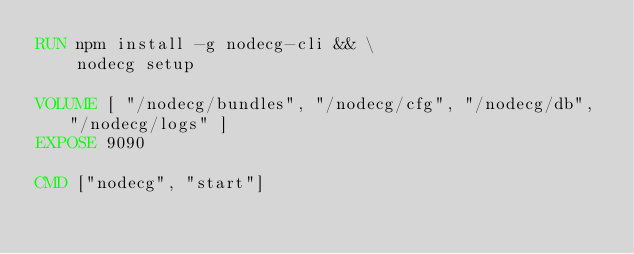<code> <loc_0><loc_0><loc_500><loc_500><_Dockerfile_>RUN npm install -g nodecg-cli && \
    nodecg setup

VOLUME [ "/nodecg/bundles", "/nodecg/cfg", "/nodecg/db", "/nodecg/logs" ]
EXPOSE 9090

CMD ["nodecg", "start"]</code> 